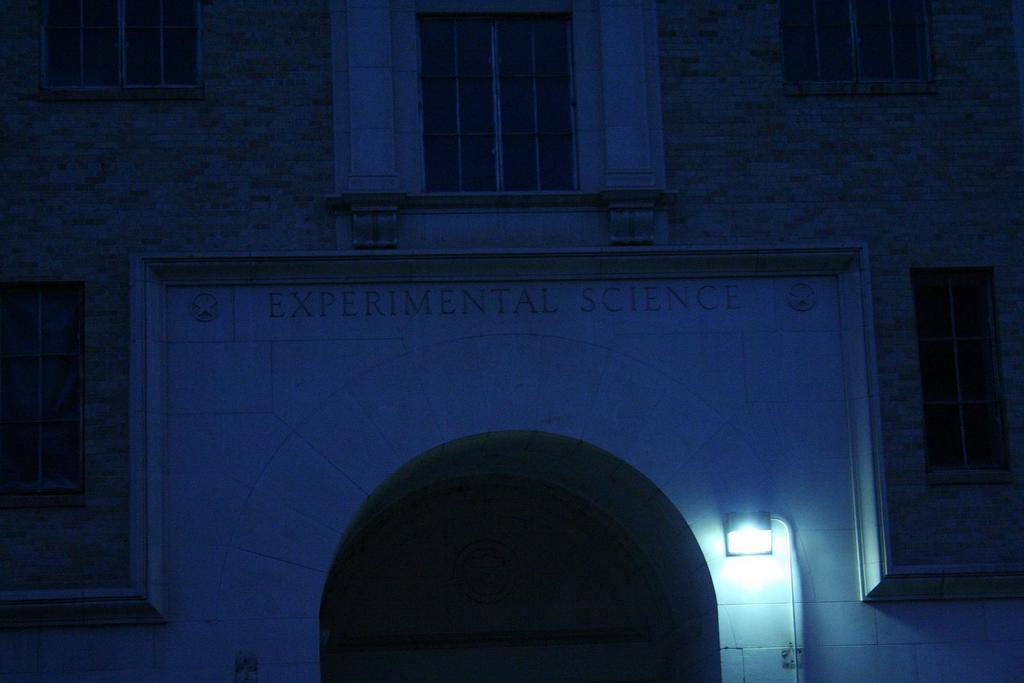Can you describe this image briefly? In this picture we can see building, windows, door, light, pole, wall and some text. 